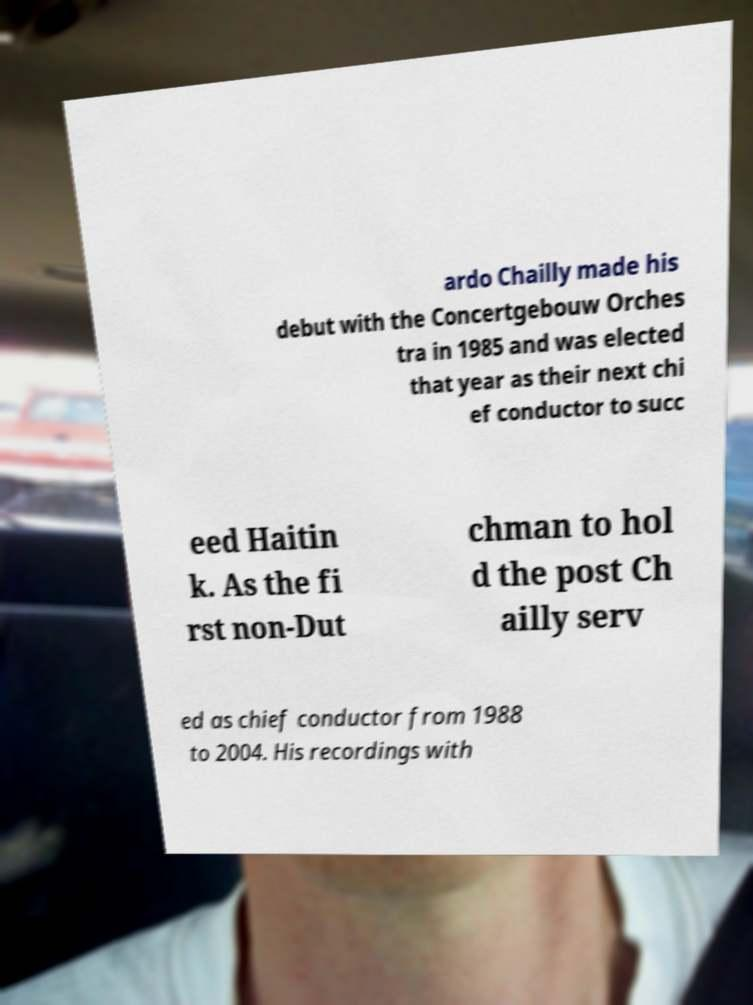Please read and relay the text visible in this image. What does it say? ardo Chailly made his debut with the Concertgebouw Orches tra in 1985 and was elected that year as their next chi ef conductor to succ eed Haitin k. As the fi rst non-Dut chman to hol d the post Ch ailly serv ed as chief conductor from 1988 to 2004. His recordings with 